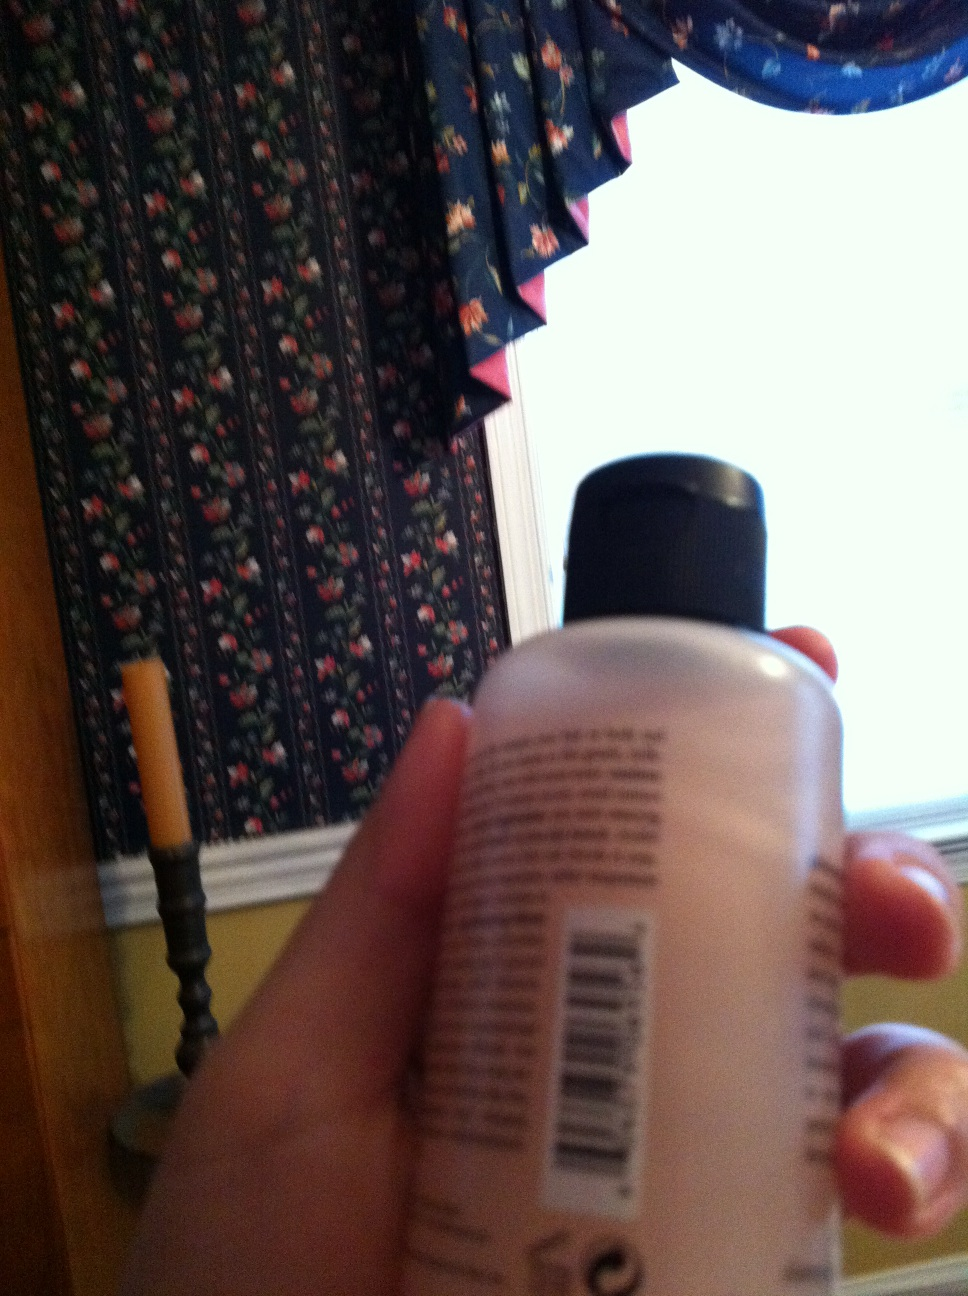Use your wildest imagination to describe a possible adventure involving the bottle in the image. In an alternate universe where everyday objects hold magical powers, this seemingly ordinary bottle contains a potion of invisibility. To anyone else, it's a simple container of hand lotion, but to the chosen one, it is the key to countless adventures. It could stealthily unlock doors in enchanted castles, explore hidden caves filled with mystical creatures, or enable the bearer to eavesdrop on secret gatherings of wizards and sorcerers. The possibilities are as limitless as the imagination allows! 